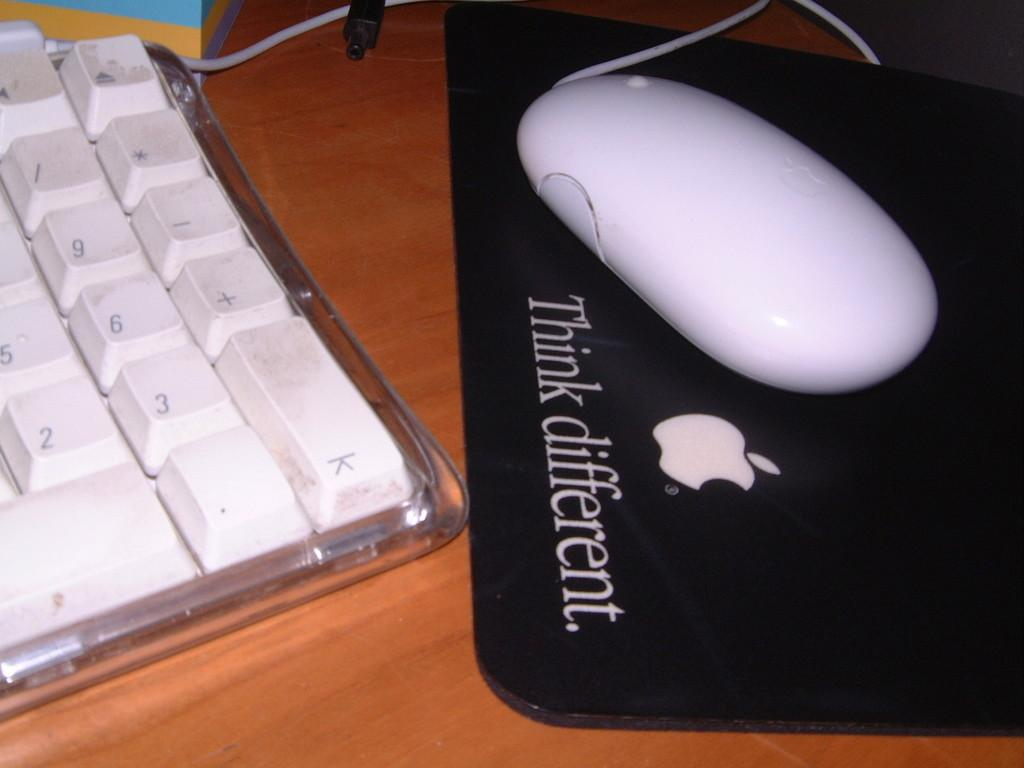Provide a one-sentence caption for the provided image. A keyboard sitting next to a Black mousepad with the words Think different printed on it with a white mouse laying on top. 